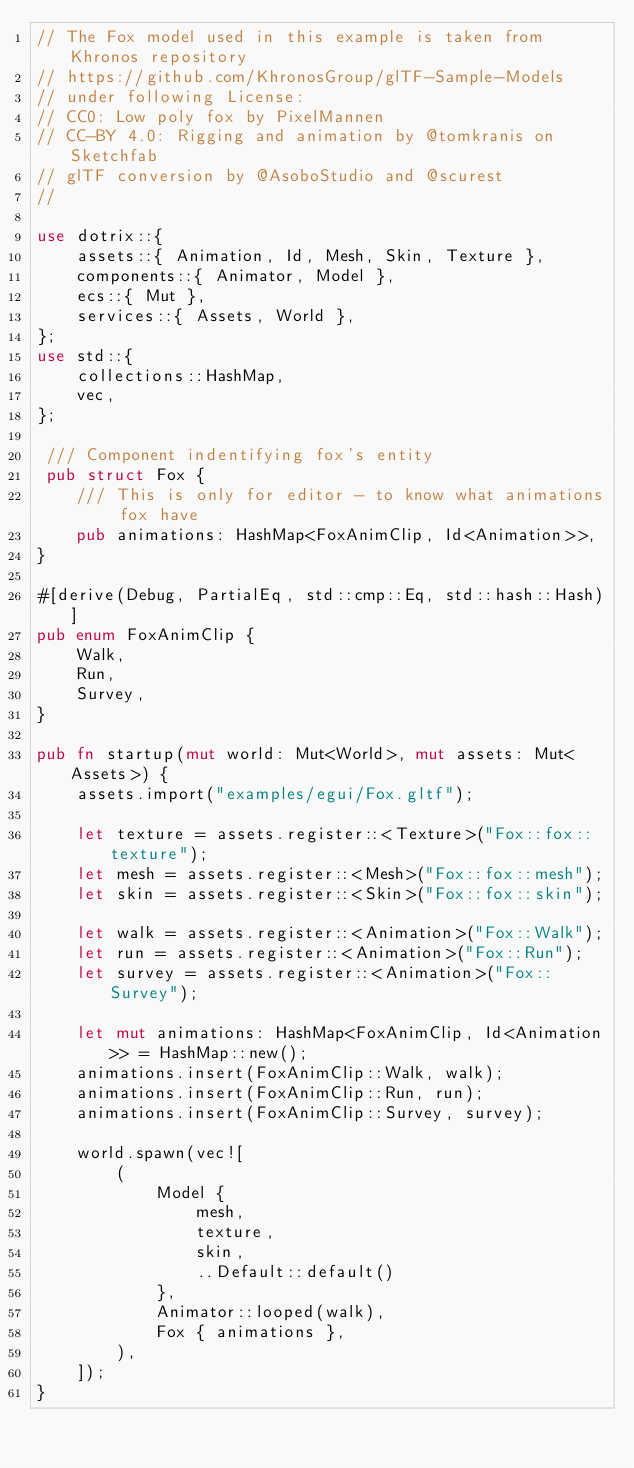<code> <loc_0><loc_0><loc_500><loc_500><_Rust_>// The Fox model used in this example is taken from Khronos repository
// https://github.com/KhronosGroup/glTF-Sample-Models
// under following License:
// CC0: Low poly fox by PixelMannen
// CC-BY 4.0: Rigging and animation by @tomkranis on Sketchfab
// glTF conversion by @AsoboStudio and @scurest
//

use dotrix::{
    assets::{ Animation, Id, Mesh, Skin, Texture },
    components::{ Animator, Model },
    ecs::{ Mut },
    services::{ Assets, World },
};
use std::{
    collections::HashMap,
    vec,
};

 /// Component indentifying fox's entity
 pub struct Fox {
    /// This is only for editor - to know what animations fox have
    pub animations: HashMap<FoxAnimClip, Id<Animation>>,
}

#[derive(Debug, PartialEq, std::cmp::Eq, std::hash::Hash)]
pub enum FoxAnimClip {
    Walk,
    Run,
    Survey,
}

pub fn startup(mut world: Mut<World>, mut assets: Mut<Assets>) {
    assets.import("examples/egui/Fox.gltf");

    let texture = assets.register::<Texture>("Fox::fox::texture");
    let mesh = assets.register::<Mesh>("Fox::fox::mesh");
    let skin = assets.register::<Skin>("Fox::fox::skin");

    let walk = assets.register::<Animation>("Fox::Walk");
    let run = assets.register::<Animation>("Fox::Run");
    let survey = assets.register::<Animation>("Fox::Survey");

    let mut animations: HashMap<FoxAnimClip, Id<Animation>> = HashMap::new();
    animations.insert(FoxAnimClip::Walk, walk);
    animations.insert(FoxAnimClip::Run, run);
    animations.insert(FoxAnimClip::Survey, survey);

    world.spawn(vec![
        (
            Model {
                mesh,
                texture,
                skin,
                ..Default::default()
            },
            Animator::looped(walk),
            Fox { animations },
        ),
    ]);
}

</code> 